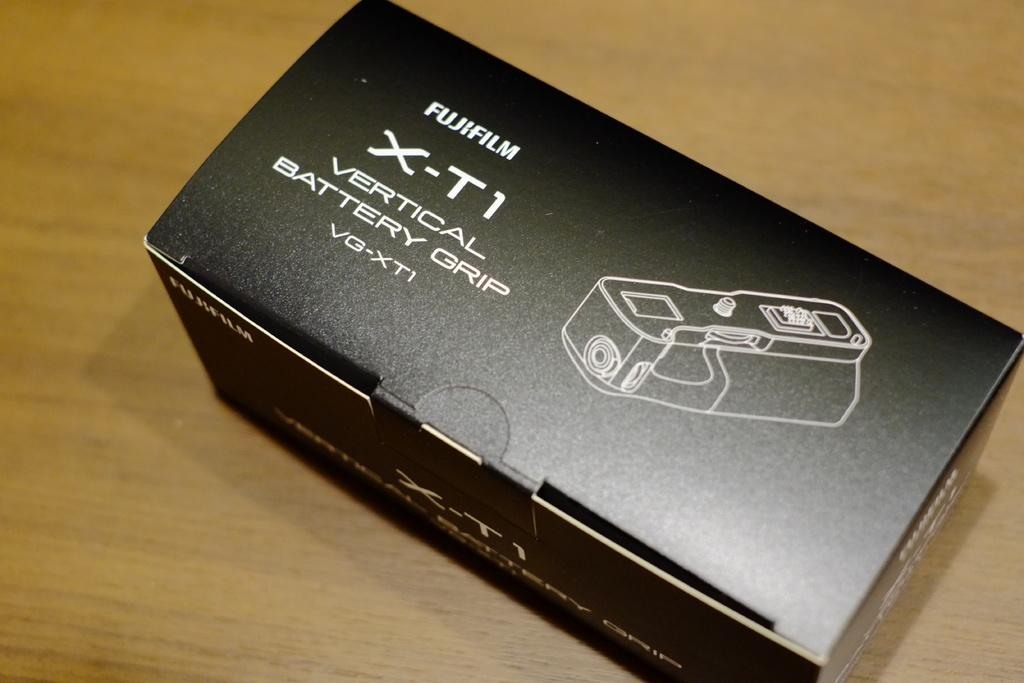<image>
Create a compact narrative representing the image presented. The box for a FujiFilm vertical battery grip 